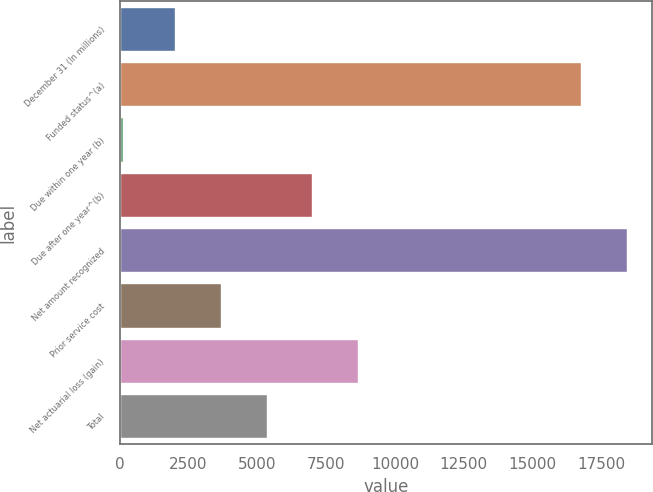Convert chart. <chart><loc_0><loc_0><loc_500><loc_500><bar_chart><fcel>December 31 (In millions)<fcel>Funded status^(a)<fcel>Due within one year (b)<fcel>Due after one year^(b)<fcel>Net amount recognized<fcel>Prior service cost<fcel>Net actuarial loss (gain)<fcel>Total<nl><fcel>2007<fcel>16753<fcel>111<fcel>6999.6<fcel>18417.2<fcel>3671.2<fcel>8663.8<fcel>5335.4<nl></chart> 